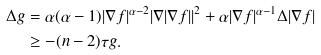<formula> <loc_0><loc_0><loc_500><loc_500>\Delta g & = \alpha ( \alpha - 1 ) | \nabla f | ^ { \alpha - 2 } | \nabla | \nabla f | | ^ { 2 } + \alpha | \nabla f | ^ { \alpha - 1 } \Delta | \nabla f | \\ & \geq - ( n - 2 ) \tau g .</formula> 